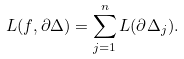<formula> <loc_0><loc_0><loc_500><loc_500>L ( f , \partial \Delta ) = \sum _ { j = 1 } ^ { n } L ( \partial \Delta _ { j } ) .</formula> 